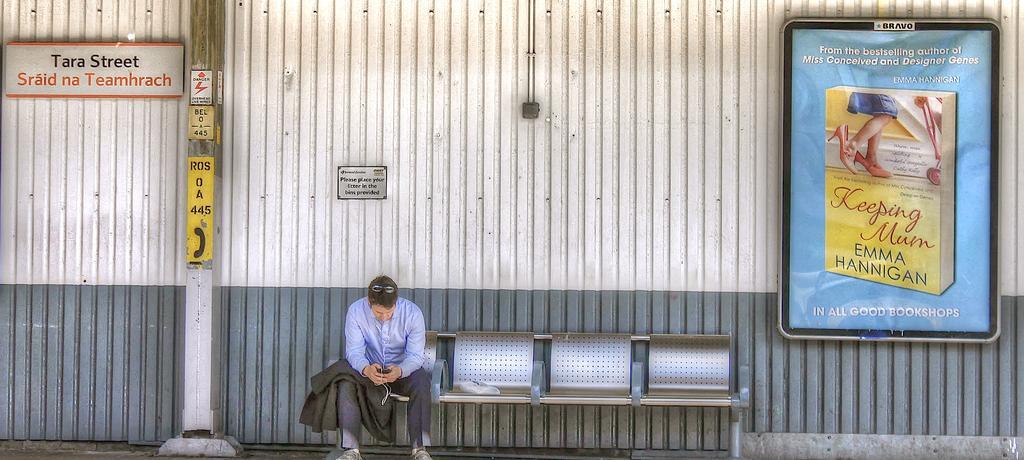Could you give a brief overview of what you see in this image? In this image we can see a person wearing shirt and holding a mobile phone and the blazer is sitting on the chair. In the background, we can see the board on which something is displayed. Here we can see the signboard with some text on it and the pole here. 